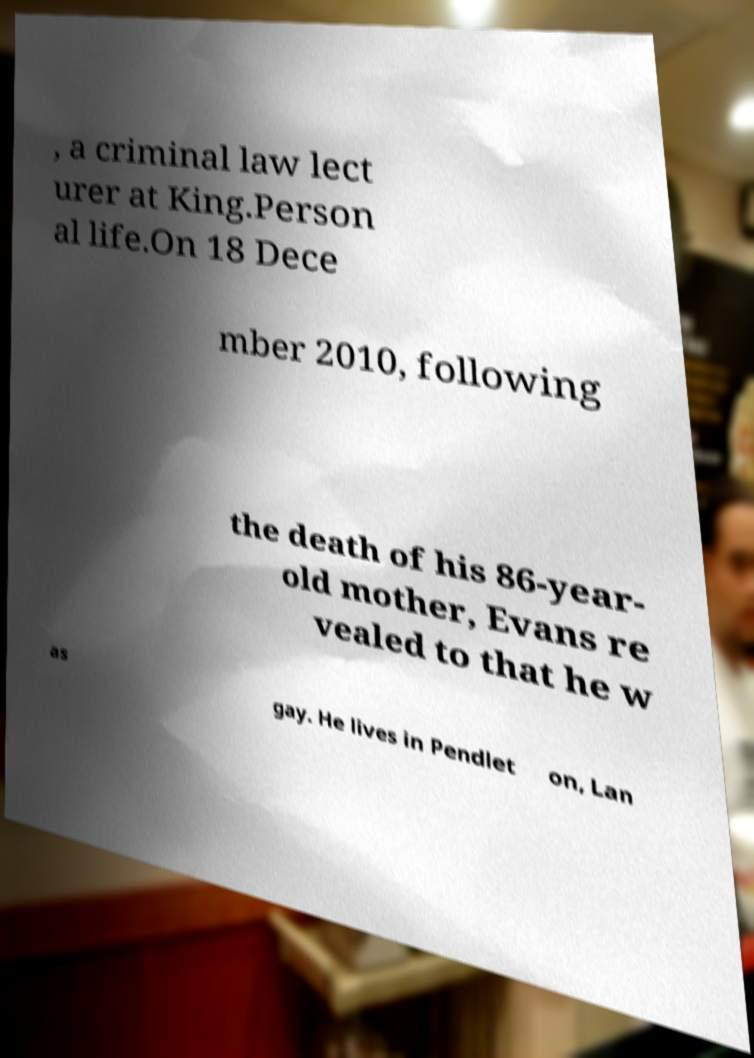I need the written content from this picture converted into text. Can you do that? , a criminal law lect urer at King.Person al life.On 18 Dece mber 2010, following the death of his 86-year- old mother, Evans re vealed to that he w as gay. He lives in Pendlet on, Lan 